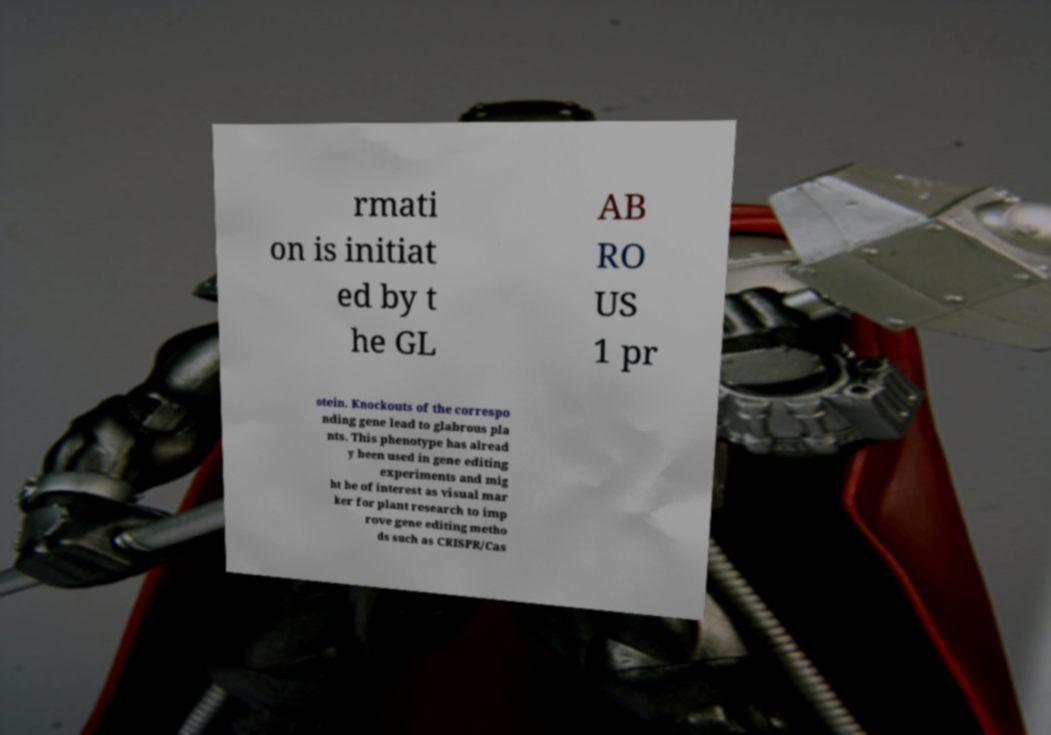Could you assist in decoding the text presented in this image and type it out clearly? rmati on is initiat ed by t he GL AB RO US 1 pr otein. Knockouts of the correspo nding gene lead to glabrous pla nts. This phenotype has alread y been used in gene editing experiments and mig ht be of interest as visual mar ker for plant research to imp rove gene editing metho ds such as CRISPR/Cas 